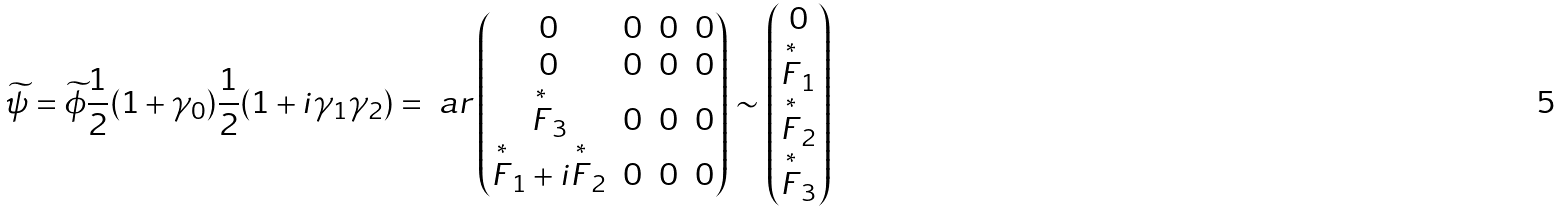<formula> <loc_0><loc_0><loc_500><loc_500>\widetilde { \psi } = \widetilde { \phi } \frac { 1 } { 2 } ( 1 + \gamma _ { 0 } ) \frac { 1 } { 2 } ( 1 + i \gamma _ { 1 } \gamma _ { 2 } ) = \ a r \begin{pmatrix} 0 & 0 & 0 & 0 \\ 0 & 0 & 0 & 0 \\ \overset { \ast } { F } _ { 3 } & 0 & 0 & 0 \\ \overset { \ast } { F } _ { 1 } + i \overset { \ast } { F } _ { 2 } & 0 & 0 & 0 \end{pmatrix} \sim \begin{pmatrix} 0 \\ \overset { \ast } { F } _ { 1 } \\ \overset { \ast } { F } _ { 2 } \\ \overset { \ast } { F } _ { 3 } \end{pmatrix}</formula> 